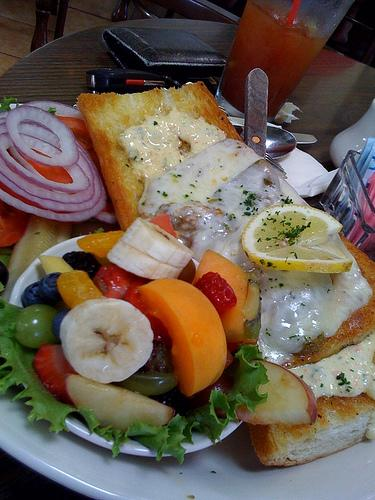What color are the onions on the top left part of the white plate? red 